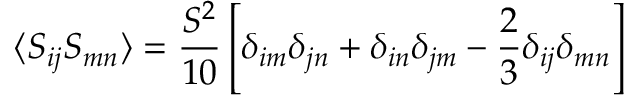<formula> <loc_0><loc_0><loc_500><loc_500>\langle S _ { i j } S _ { m n } \rangle = \frac { S ^ { 2 } } { 1 0 } \left [ \delta _ { i m } \delta _ { j n } + \delta _ { i n } \delta _ { j m } - \frac { 2 } { 3 } \delta _ { i j } \delta _ { m n } \right ]</formula> 